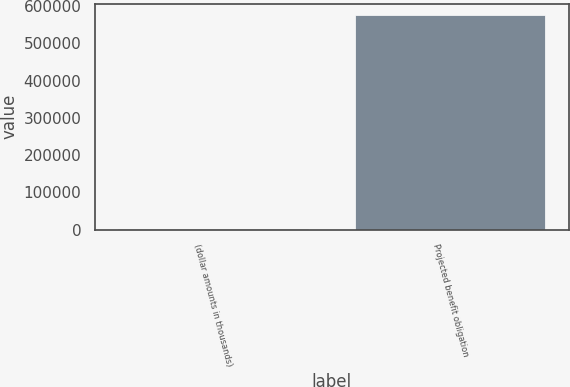Convert chart to OTSL. <chart><loc_0><loc_0><loc_500><loc_500><bar_chart><fcel>(dollar amounts in thousands)<fcel>Projected benefit obligation<nl><fcel>2011<fcel>577770<nl></chart> 